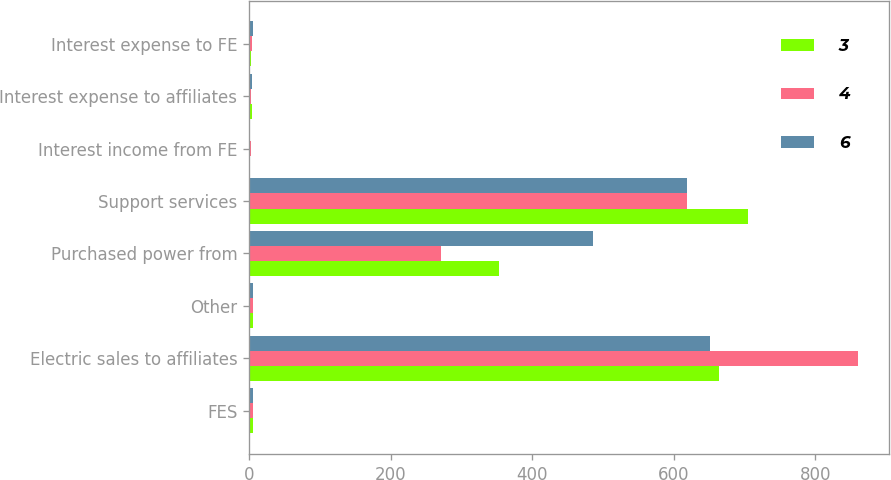Convert chart to OTSL. <chart><loc_0><loc_0><loc_500><loc_500><stacked_bar_chart><ecel><fcel>FES<fcel>Electric sales to affiliates<fcel>Other<fcel>Purchased power from<fcel>Support services<fcel>Interest income from FE<fcel>Interest expense to affiliates<fcel>Interest expense to FE<nl><fcel>3<fcel>6<fcel>664<fcel>6<fcel>353<fcel>705<fcel>2<fcel>4<fcel>3<nl><fcel>4<fcel>6<fcel>861<fcel>6<fcel>271<fcel>619<fcel>3<fcel>3<fcel>4<nl><fcel>6<fcel>6<fcel>652<fcel>6<fcel>486<fcel>619<fcel>2<fcel>4<fcel>6<nl></chart> 